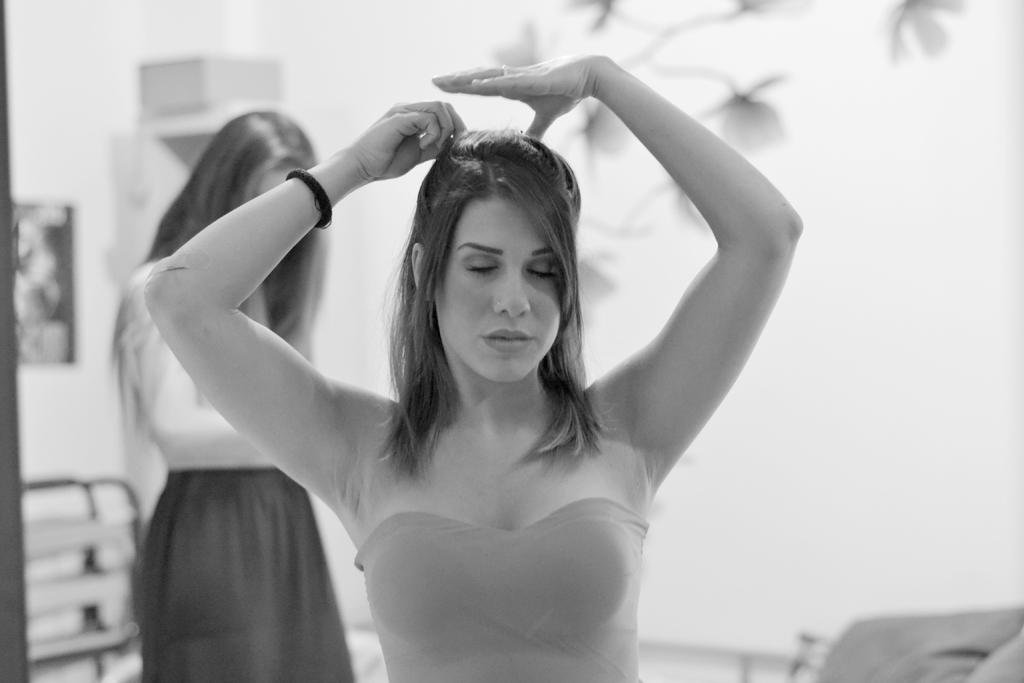How many people are in the image? There are two women in the image. What are the women doing in the image? The women appear to be standing. Can you describe any other objects or features visible in the background of the image? Unfortunately, the provided facts do not give any information about the background of the image. What type of comfort does the dad provide to the honey in the image? There is no dad or honey present in the image, so this question cannot be answered. 